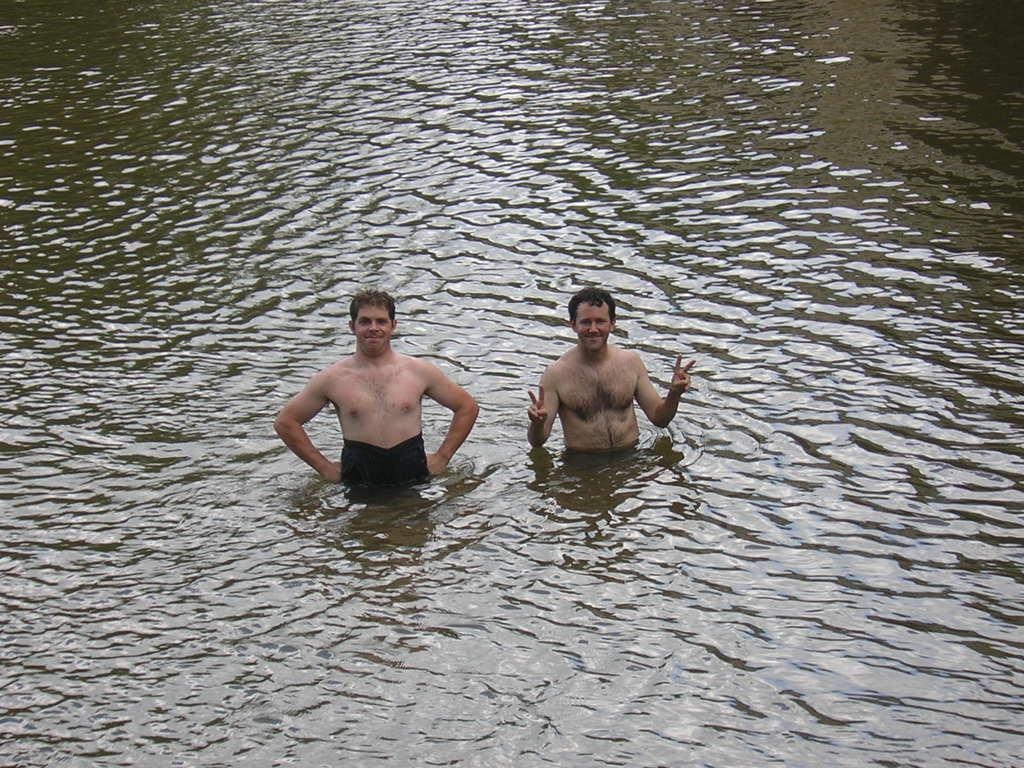Who or what can be seen in the image? There are people in the image. Can you describe the setting or location of the people? The people are in the water. What story is being told by the people in the water? There is no story being told by the people in the water; the image only shows them being in the water. 